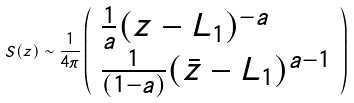<formula> <loc_0><loc_0><loc_500><loc_500>S ( z ) \sim \frac { 1 } { 4 \pi } \left ( \begin{array} { l } \frac { 1 } { a } ( z - L _ { 1 } ) ^ { - a } \\ \frac { 1 } { ( 1 - a ) } ( \bar { z } - L _ { 1 } ) ^ { a - 1 } \end{array} \right )</formula> 